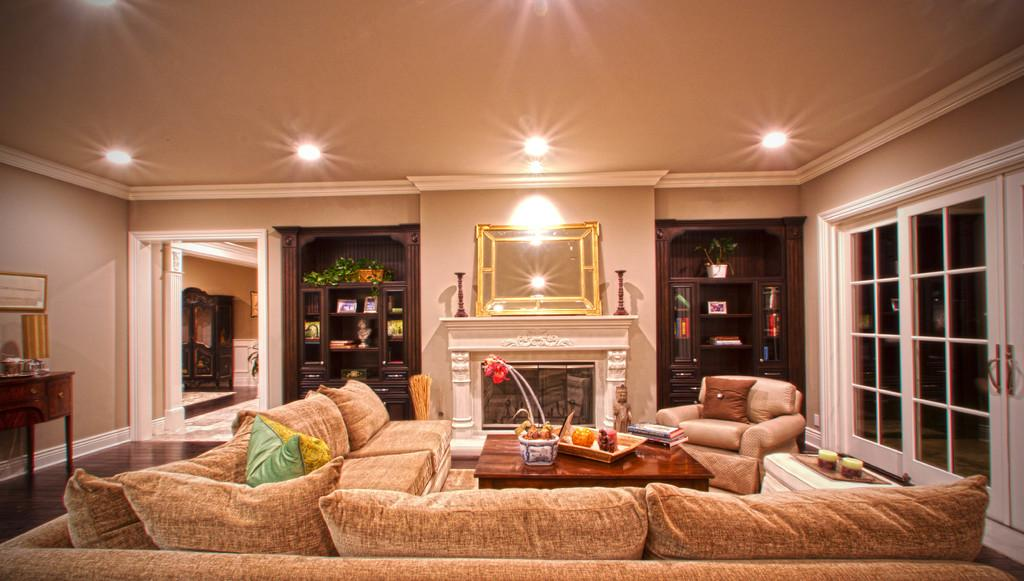What type of furniture is present in the room? There is a sofa, a table, a water plant, cupboards, books, a door, and a chair in the room. Can you describe the arrangement of the furniture? The table is on the right side, and there is a chair next to it. What is on the table? There are books on the table. Are there any light sources in the room? Yes, there are lights on the rooftop. How much sugar is present in the water plant in the room? There is no sugar present in the water plant in the room; it is a plant that grows in water. Is there any oil visible on the table in the room? There is no mention of oil in the room, so it cannot be determined if it is present on the table. 